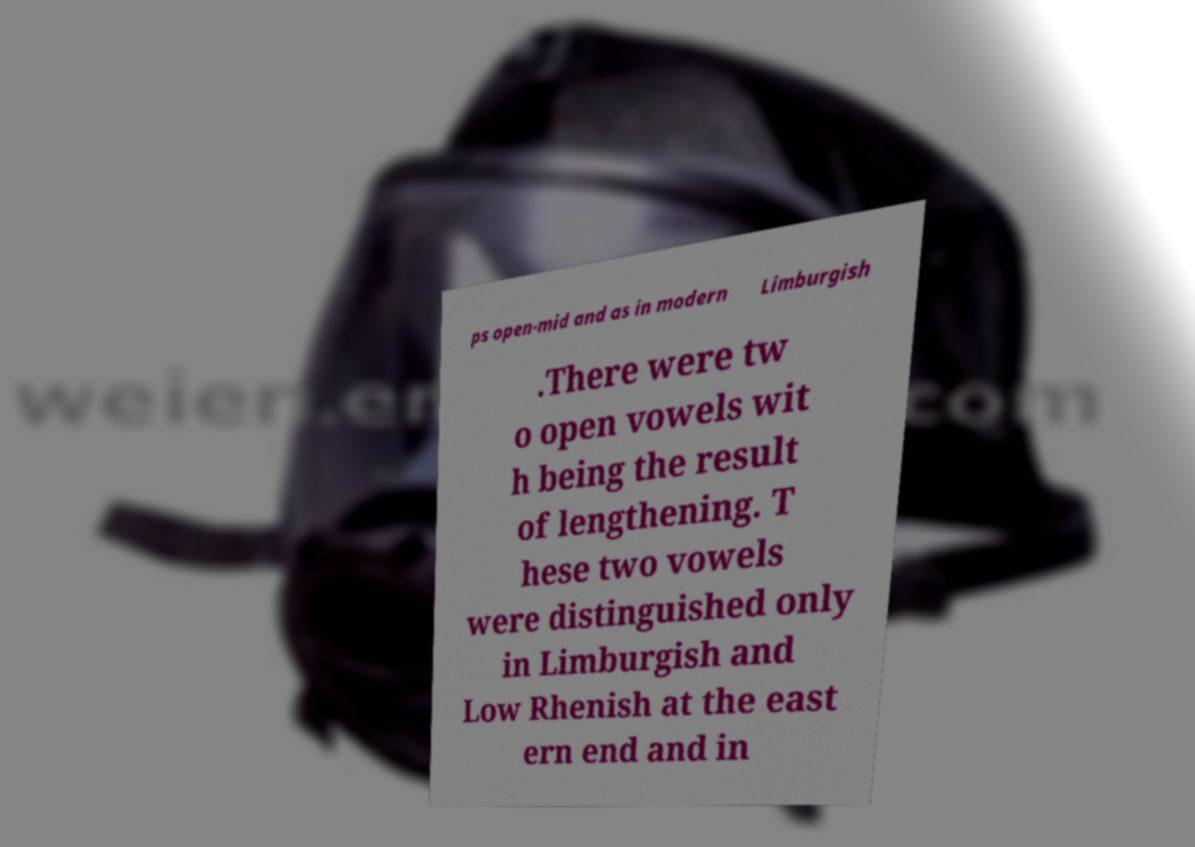Please identify and transcribe the text found in this image. ps open-mid and as in modern Limburgish .There were tw o open vowels wit h being the result of lengthening. T hese two vowels were distinguished only in Limburgish and Low Rhenish at the east ern end and in 